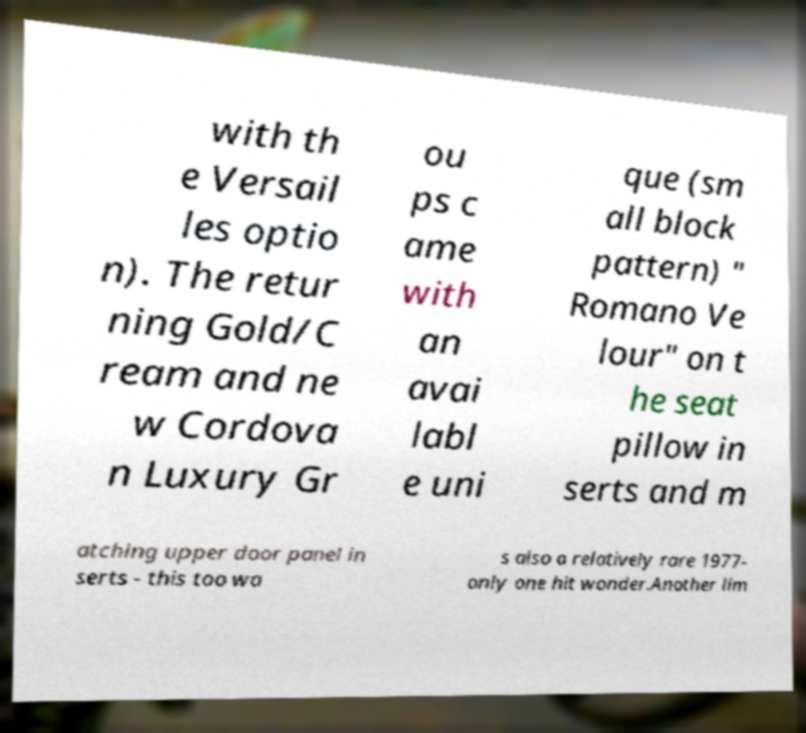What messages or text are displayed in this image? I need them in a readable, typed format. with th e Versail les optio n). The retur ning Gold/C ream and ne w Cordova n Luxury Gr ou ps c ame with an avai labl e uni que (sm all block pattern) " Romano Ve lour" on t he seat pillow in serts and m atching upper door panel in serts - this too wa s also a relatively rare 1977- only one hit wonder.Another lim 